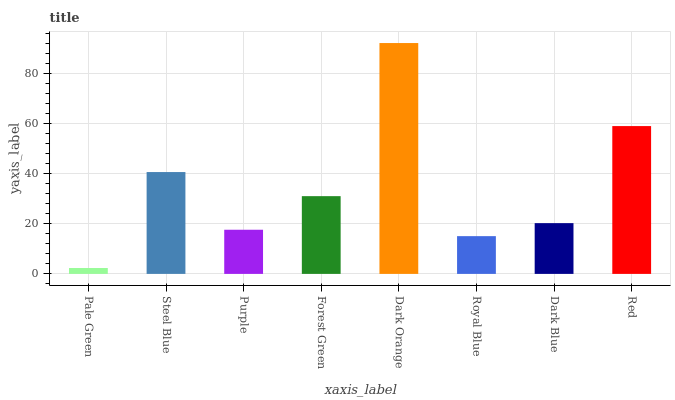Is Steel Blue the minimum?
Answer yes or no. No. Is Steel Blue the maximum?
Answer yes or no. No. Is Steel Blue greater than Pale Green?
Answer yes or no. Yes. Is Pale Green less than Steel Blue?
Answer yes or no. Yes. Is Pale Green greater than Steel Blue?
Answer yes or no. No. Is Steel Blue less than Pale Green?
Answer yes or no. No. Is Forest Green the high median?
Answer yes or no. Yes. Is Dark Blue the low median?
Answer yes or no. Yes. Is Dark Blue the high median?
Answer yes or no. No. Is Steel Blue the low median?
Answer yes or no. No. 